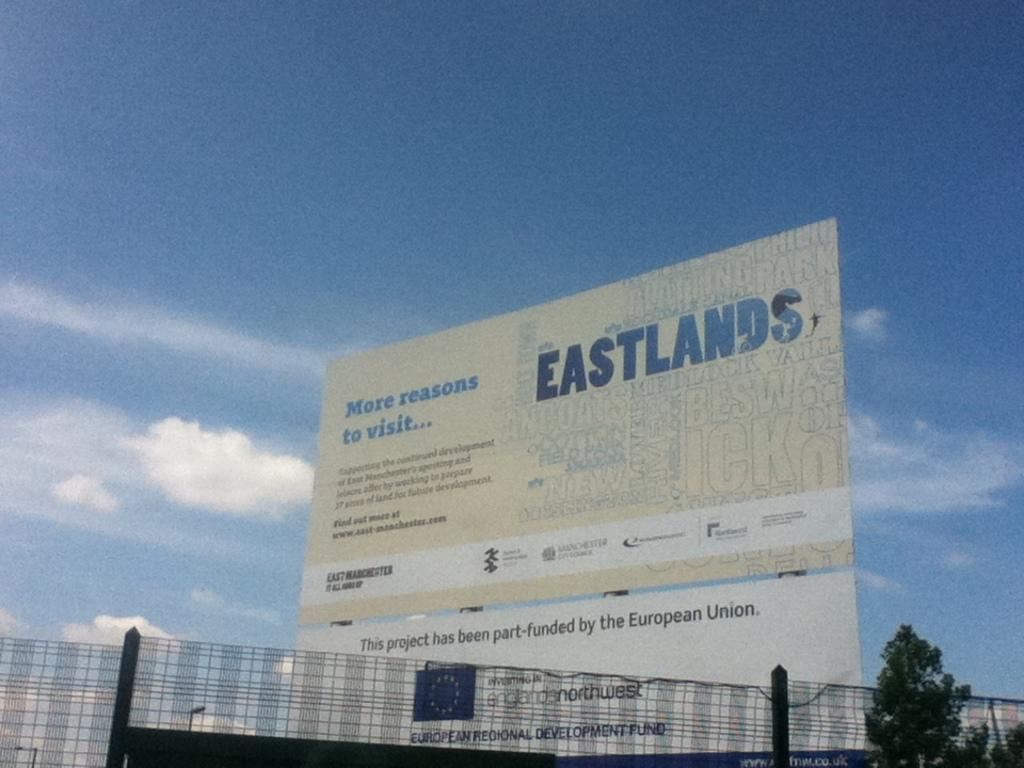<image>
Render a clear and concise summary of the photo. a sign that has the word Eastlands on it in the daytime 